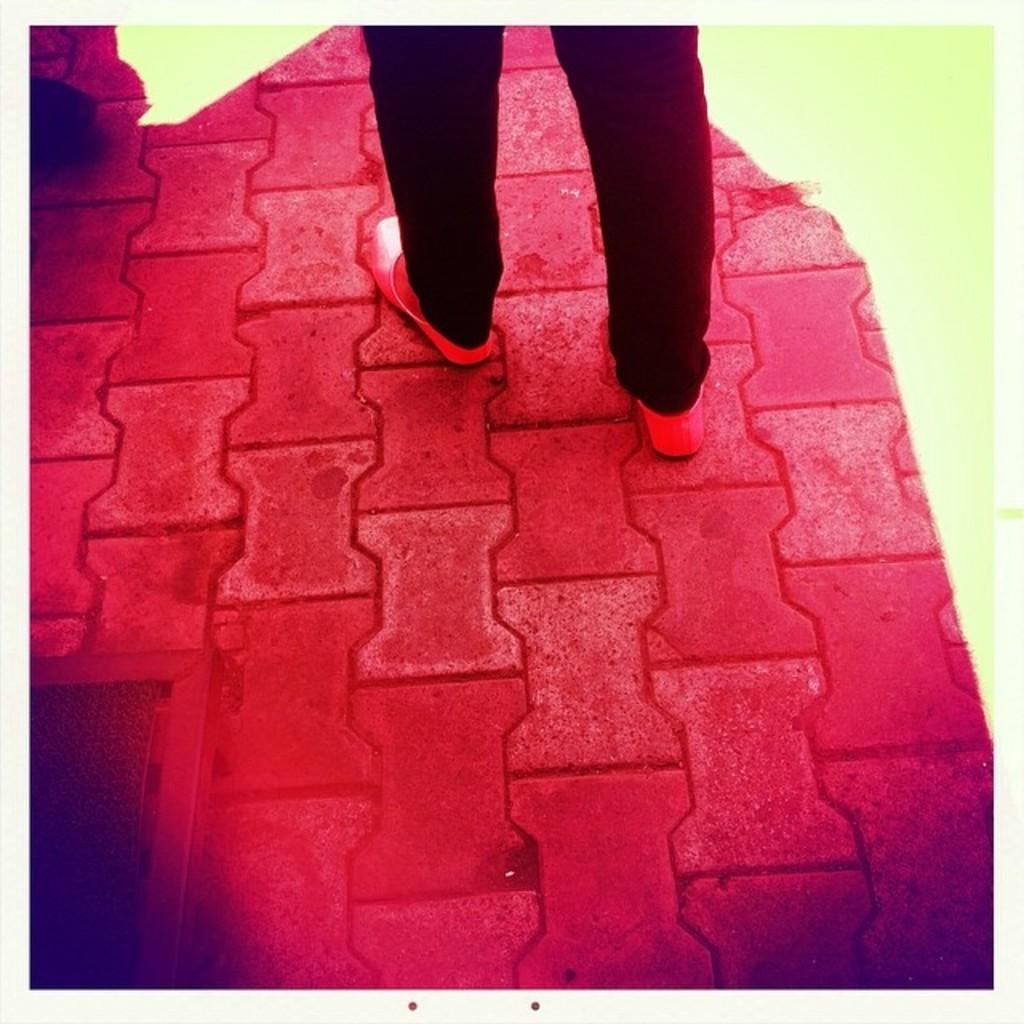What is the primary subject in the image? There is a human standing in the image. Which part of the human's body can be seen in the image? The human's legs are visible in the image. What can be observed about the ground in the image? There are colors on the ground in the image. What is the human's taste preference in the image? There is no information about the human's taste preference in the image. 